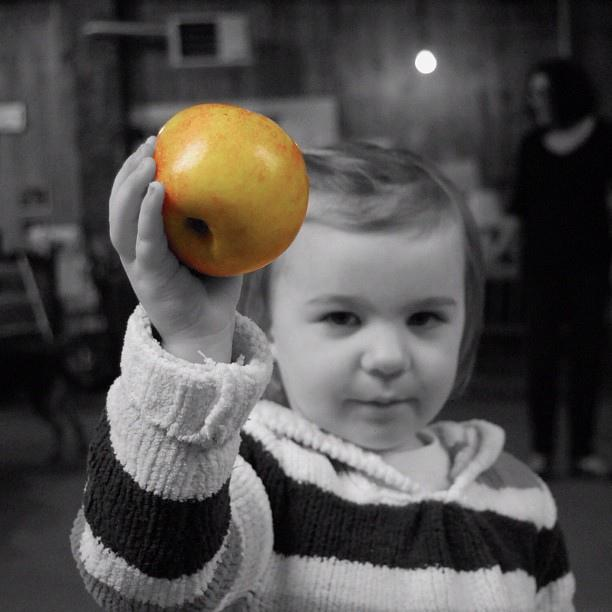What happens to the image? Please explain your reasoning. photoshopped. The image has emphasized the apple with photoshop. 